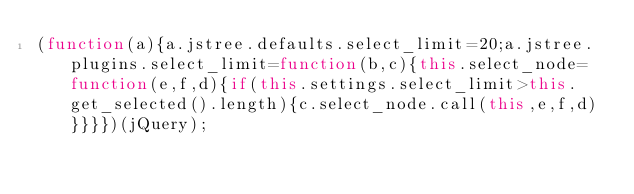Convert code to text. <code><loc_0><loc_0><loc_500><loc_500><_JavaScript_>(function(a){a.jstree.defaults.select_limit=20;a.jstree.plugins.select_limit=function(b,c){this.select_node=function(e,f,d){if(this.settings.select_limit>this.get_selected().length){c.select_node.call(this,e,f,d)}}}})(jQuery);</code> 